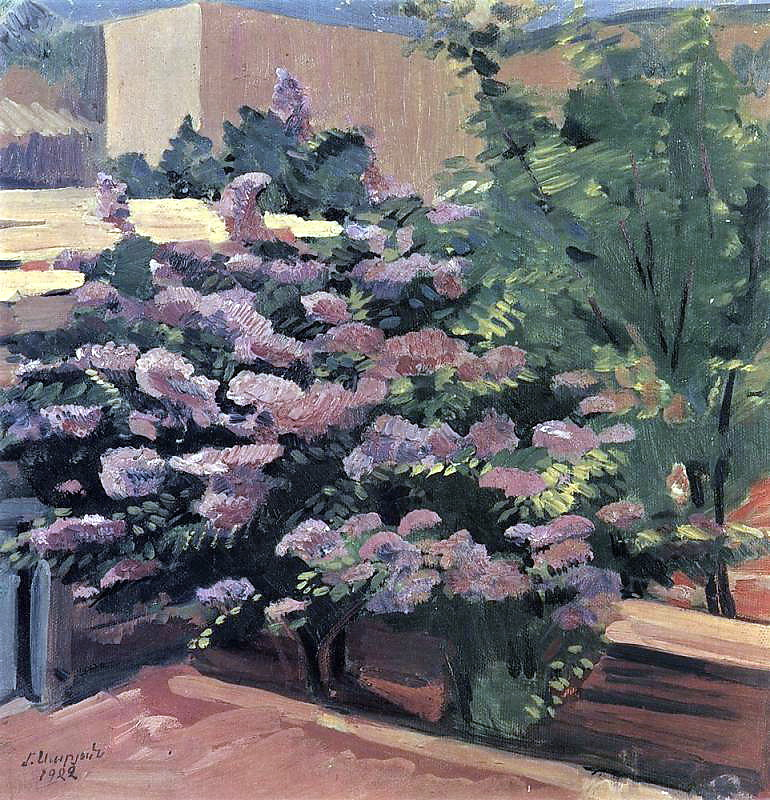What themes does this painting explore? This painting explores themes of nature's beauty, tranquility, and the fleeting moments of serenity found in everyday life. The focus on a blooming garden highlights the theme of growth and the natural cycle of life. The harmonious blend of colors and the gentle depiction of light and shade suggest a theme of calmness and peaceful reflection. The impressionist style of the painting, with its emphasis on capturing the sensory experience rather than fine details, underscores a theme of appreciating the simple, ephemeral moments that bring joy and relaxation. The artwork also touches on the theme of timelessness, as it captures a scene that could be from any era, evoking a sense of continuity and connection with nature. How might the painting be different if it were set in winter? If the painting were set in winter, the scene would likely have a completely different atmosphere. The vibrant pink and purple flowers would be replaced by bare branches or perhaps evergreens dusted with snow. The lush green foliage would be subdued or absent, and the overall color palette would shift to cooler tones—whites, blues, and grays. The sky might appear more overcast, adding to a sense of quiet and stillness. The garden, now in dormancy, would evoke feelings of solitude and reflection, contrasting with the lively growth depicted in the original painting. The play of light would be softer, with subtle shadows cast by the winter sun, and the ground might be covered with a blanket of snow, adding a serene and pristine quality to the scene. 